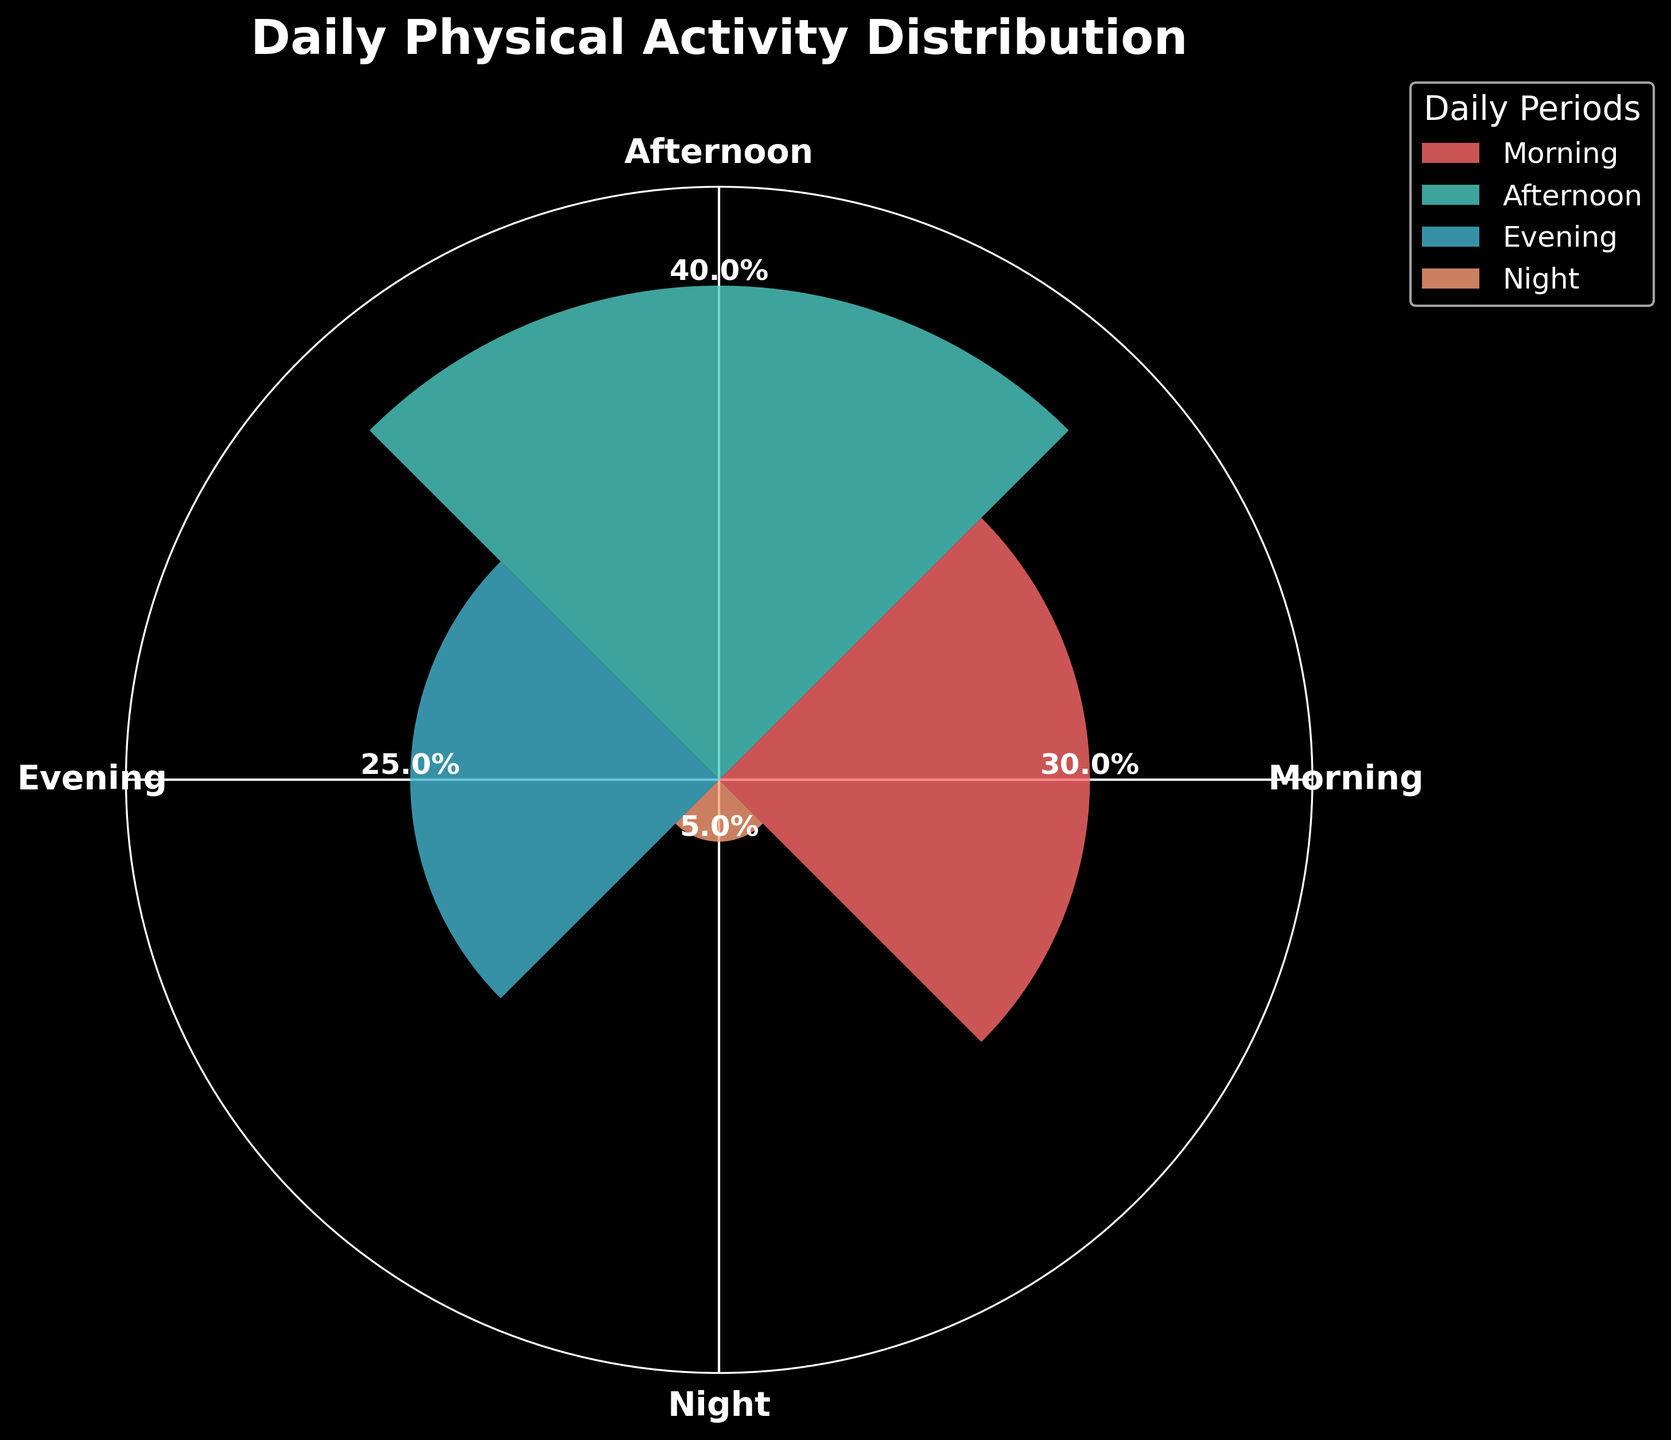What's the title of the plot? The title is usually positioned at the top and is prominent in the figure. Here, the title is written at the top as "Daily Physical Activity Distribution."
Answer: Daily Physical Activity Distribution How many daily periods are represented in the figure? Count the distinct labels around the polar plot. There are labels indicating Morning, Afternoon, Evening, and Night.
Answer: Four Which daily period has the highest activity level? Compare the heights of the bars, the tallest bar corresponds to the “Afternoon” period.
Answer: Afternoon What percentage of the activity occurs during the Night? Look for the label near the Night bar. The text shows a value of 5%.
Answer: 5% What are the colors used in the plot, and which color represents Morning? Identify the different colors used in the bars. Morning is represented with a color resembling red (the first bar).
Answer: Red What's the combined activity level for Morning and Evening? Add the activity levels for Morning (30%) and Evening (25%). 30% + 25% equals 55%.
Answer: 55% During which periods does 70% of the activity take place? Identify and sum the activity levels until reaching 70%. Morning (30%) + Afternoon (40%) equals 70%.
Answer: Morning, Afternoon Which period has the lowest activity level and what is the level? Identify the shortest bar and read its percentage value. It corresponds to the Night period with 5%.
Answer: Night, 5% How much higher is the activity level in the Afternoon compared to the Evening? Subtract the Evening activity level (25%) from the Afternoon activity level (40%). 40% - 25% equals 15%.
Answer: 15% higher If activity levels for Morning and Evening combined represent 55%, what percentage is represented by the remaining periods? Subtract the combined percentage of Morning and Evening from 100%. 100% - 55% equals 45%.
Answer: 45% 